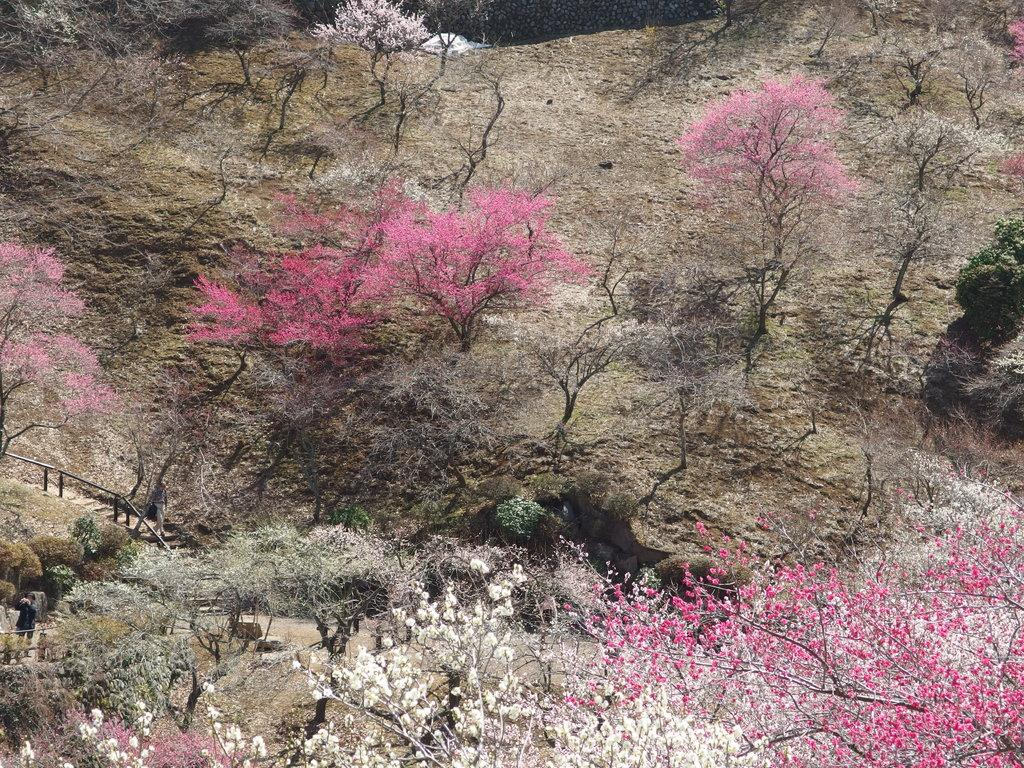What type of vegetation can be seen in the image? There are trees, plants, and flowers in the image. Can you describe the different types of flora present in the image? The image contains trees, plants, and flowers. What might be the purpose of the plants and flowers in the image? The plants and flowers in the image could be for decoration or to attract pollinators. What type of match can be seen in the image? There is no match present in the image. What color is the brick in the image? There is no brick present in the image. 